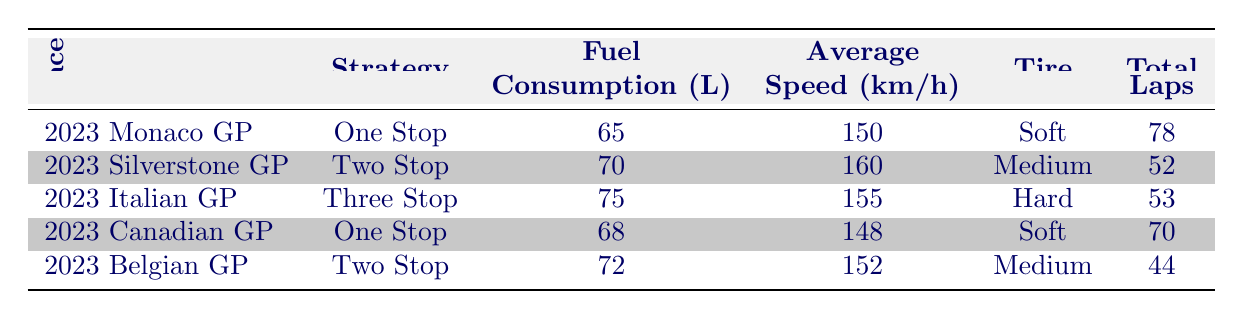What was the fuel consumption for the 2023 Monaco Grand Prix? The table lists the fuel consumption for the 2023 Monaco Grand Prix as 65 liters.
Answer: 65 liters Which race had the highest average speed? Comparing the average speed values in the table, the 2023 Silverstone Grand Prix had the highest average speed of 160 km/h.
Answer: 2023 Silverstone Grand Prix What is the total number of laps for races that used the medium tire type? From the table, the races with the medium tire type are the Silverstone and Belgian Grand Prix. Their total laps are 52 (Silverstone) + 44 (Belgian) = 96.
Answer: 96 laps Did the three-stop strategy consume more fuel than the one-stop strategies? The three-stop strategy had a fuel consumption of 75 liters, while the one-stop strategies consumed 65 liters (Monaco) and 68 liters (Canadian), which are both less than 75 liters. So, yes, the three-stop strategy consumed more fuel.
Answer: Yes Calculate the average fuel consumption of all strategies listed in the table. The fuel consumptions are 65, 70, 75, 68, and 72 liters. Summing them gives 65 + 70 + 75 + 68 + 72 = 350 liters. Since there are 5 races, the average is 350 liters / 5 = 70 liters.
Answer: 70 liters Which strategy had the least fuel consumption? The table shows that the one-stop strategy during the 2023 Monaco Grand Prix had the least fuel consumption of 65 liters among all the strategies listed.
Answer: 65 liters Is it true that every race with a "One Stop" strategy had an average speed of over 145 km/h? The average speeds for the one-stop races were 150 km/h (Monaco) and 148 km/h (Canadian), both are indeed over 145 km/h, so the statement is true.
Answer: Yes Were more total laps completed in the Belgium GP than in the Canadian GP? The table indicates that the Belgian GP had a total of 44 laps while the Canadian GP had 70 laps. Thus, fewer laps were completed in the Belgian GP compared to the Canadian GP.
Answer: No 